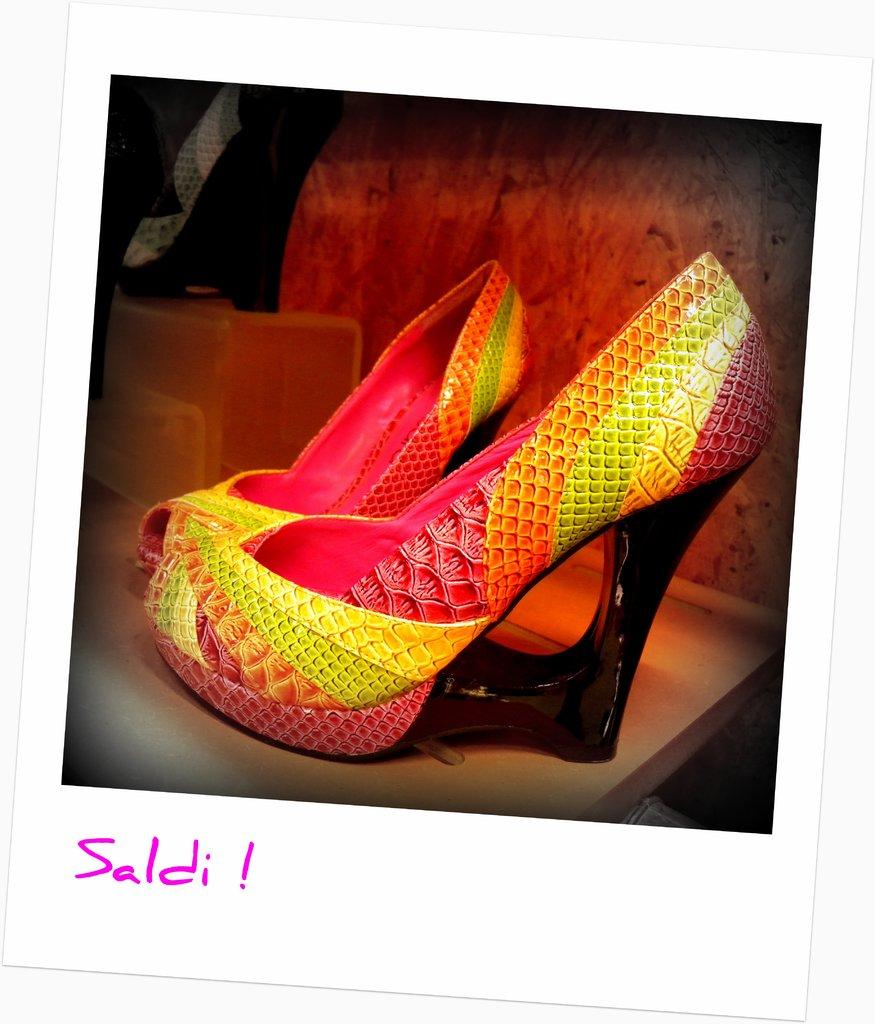What is the main subject of the image? There is a photo in the image. What can be seen in the photo? There are ladies shoes in the photo. What type of chicken is present in the photo? There is no chicken present in the photo; it only features ladies shoes. 